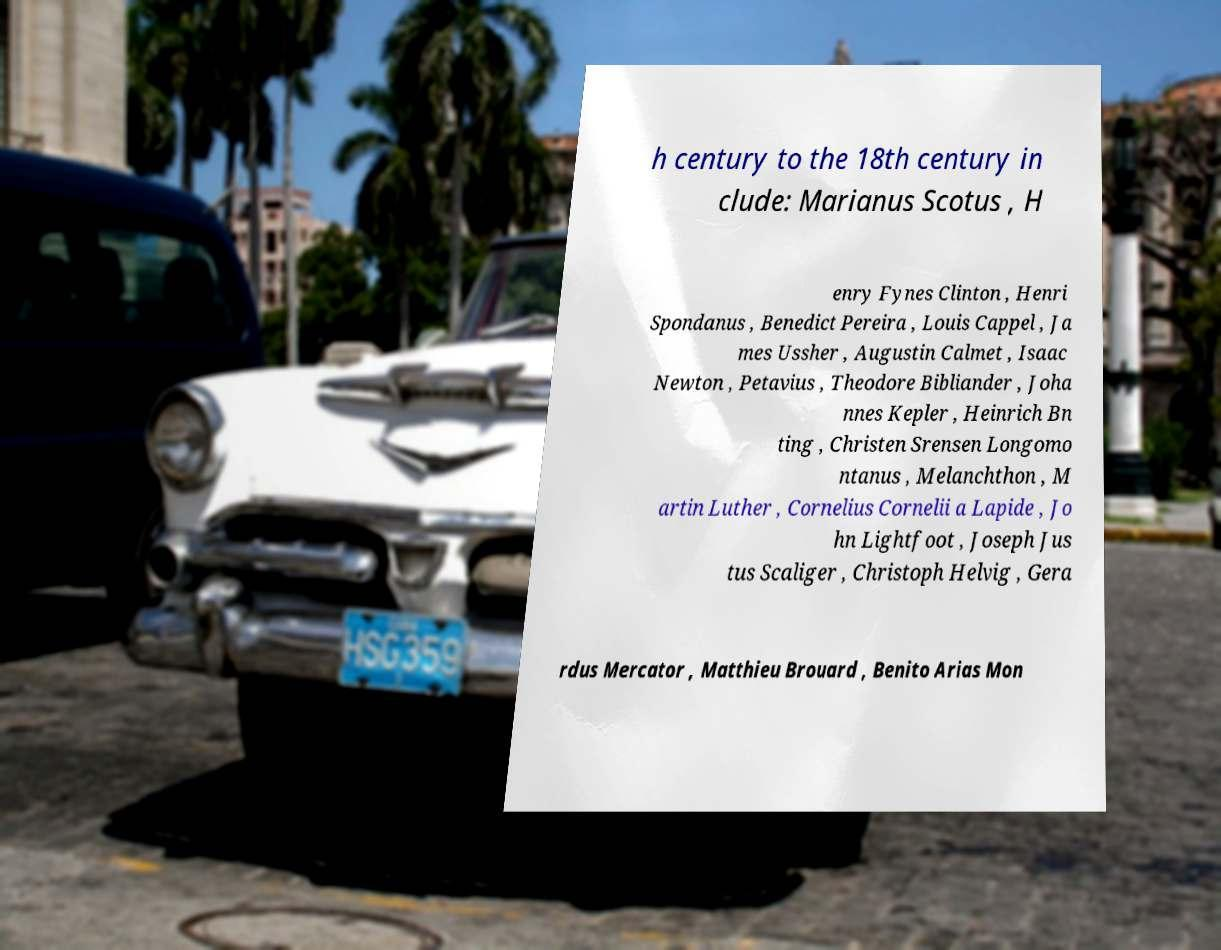Can you accurately transcribe the text from the provided image for me? h century to the 18th century in clude: Marianus Scotus , H enry Fynes Clinton , Henri Spondanus , Benedict Pereira , Louis Cappel , Ja mes Ussher , Augustin Calmet , Isaac Newton , Petavius , Theodore Bibliander , Joha nnes Kepler , Heinrich Bn ting , Christen Srensen Longomo ntanus , Melanchthon , M artin Luther , Cornelius Cornelii a Lapide , Jo hn Lightfoot , Joseph Jus tus Scaliger , Christoph Helvig , Gera rdus Mercator , Matthieu Brouard , Benito Arias Mon 